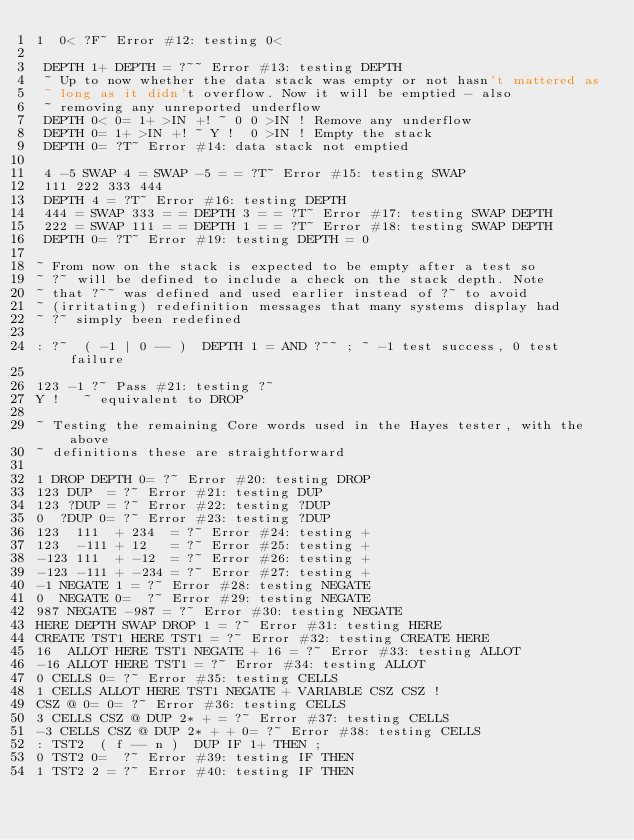<code> <loc_0><loc_0><loc_500><loc_500><_Forth_>1  0< ?F~ Error #12: testing 0<

 DEPTH 1+ DEPTH = ?~~ Error #13: testing DEPTH
 ~ Up to now whether the data stack was empty or not hasn't mattered as
 ~ long as it didn't overflow. Now it will be emptied - also
 ~ removing any unreported underflow
 DEPTH 0< 0= 1+ >IN +! ~ 0 0 >IN ! Remove any underflow
 DEPTH 0= 1+ >IN +! ~ Y !  0 >IN ! Empty the stack
 DEPTH 0= ?T~ Error #14: data stack not emptied

 4 -5 SWAP 4 = SWAP -5 = = ?T~ Error #15: testing SWAP
 111 222 333 444
 DEPTH 4 = ?T~ Error #16: testing DEPTH
 444 = SWAP 333 = = DEPTH 3 = = ?T~ Error #17: testing SWAP DEPTH
 222 = SWAP 111 = = DEPTH 1 = = ?T~ Error #18: testing SWAP DEPTH
 DEPTH 0= ?T~ Error #19: testing DEPTH = 0

~ From now on the stack is expected to be empty after a test so
~ ?~ will be defined to include a check on the stack depth. Note
~ that ?~~ was defined and used earlier instead of ?~ to avoid
~ (irritating) redefinition messages that many systems display had
~ ?~ simply been redefined

: ?~  ( -1 | 0 -- )  DEPTH 1 = AND ?~~ ; ~ -1 test success, 0 test failure

123 -1 ?~ Pass #21: testing ?~
Y !   ~ equivalent to DROP

~ Testing the remaining Core words used in the Hayes tester, with the above
~ definitions these are straightforward

1 DROP DEPTH 0= ?~ Error #20: testing DROP
123 DUP  = ?~ Error #21: testing DUP
123 ?DUP = ?~ Error #22: testing ?DUP
0  ?DUP 0= ?~ Error #23: testing ?DUP
123  111  + 234  = ?~ Error #24: testing +
123  -111 + 12   = ?~ Error #25: testing +
-123 111  + -12  = ?~ Error #26: testing +
-123 -111 + -234 = ?~ Error #27: testing +
-1 NEGATE 1 = ?~ Error #28: testing NEGATE
0  NEGATE 0=  ?~ Error #29: testing NEGATE
987 NEGATE -987 = ?~ Error #30: testing NEGATE
HERE DEPTH SWAP DROP 1 = ?~ Error #31: testing HERE
CREATE TST1 HERE TST1 = ?~ Error #32: testing CREATE HERE
16  ALLOT HERE TST1 NEGATE + 16 = ?~ Error #33: testing ALLOT
-16 ALLOT HERE TST1 = ?~ Error #34: testing ALLOT
0 CELLS 0= ?~ Error #35: testing CELLS
1 CELLS ALLOT HERE TST1 NEGATE + VARIABLE CSZ CSZ !
CSZ @ 0= 0= ?~ Error #36: testing CELLS
3 CELLS CSZ @ DUP 2* + = ?~ Error #37: testing CELLS
-3 CELLS CSZ @ DUP 2* + + 0= ?~ Error #38: testing CELLS
: TST2  ( f -- n )  DUP IF 1+ THEN ;
0 TST2 0=  ?~ Error #39: testing IF THEN
1 TST2 2 = ?~ Error #40: testing IF THEN</code> 